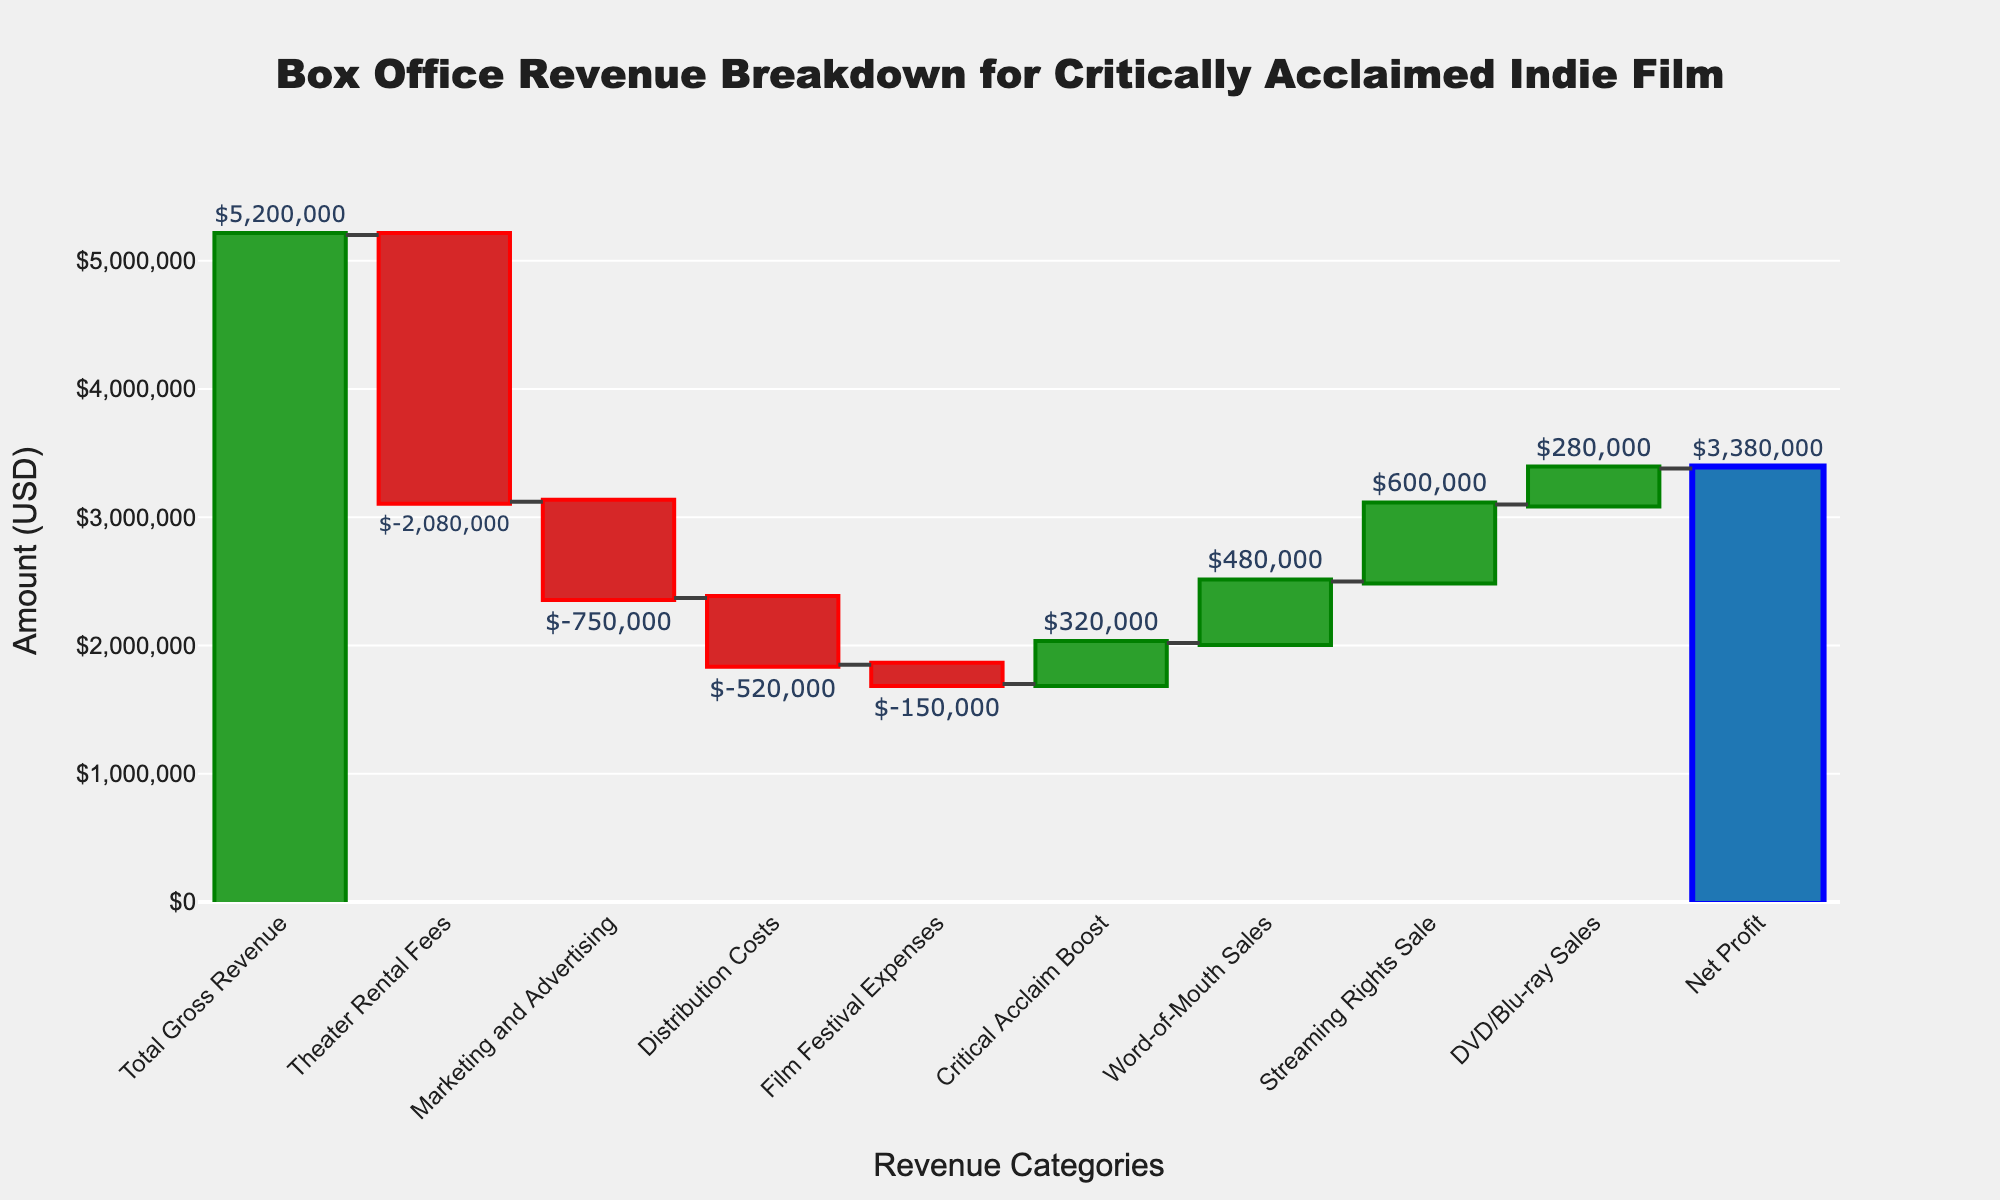What's the title of the chart? The title of the chart is typically displayed at the top and is meant to give an overview of the visualized data. In this case, the title is clearly indicated.
Answer: Box Office Revenue Breakdown for Critically Acclaimed Indie Film What is the value of the Net Profit? To find the Net Profit, look for the bar labeled "Net Profit" in the chart and read the value attached to it.
Answer: $3,380,000 How much are the Theater Rental Fees? Find the bar labeled "Theater Rental Fees" and note the value associated with it.
Answer: $-2,080,000 Which category contributes the most positively to the revenue after the "Total Gross Revenue"? Observe which of the green bars has the highest value.
Answer: Streaming Rights Sale What is the sum of Marketing and Advertising and Distribution Costs? Add the values of Marketing and Advertising ($-750,000) and Distribution Costs ($-520,000).
Answer: $-1,270,000 What are the two expenses with the smallest absolute values? By comparing the absolute values of the expenses, identify the two smallest ones.
Answer: Film Festival Expenses and Critical Acclaim Boost How much more revenue did the Word-of-Mouth Sales generate compared to Critical Acclaim Boost? Calculate the difference between the value of Word-of-Mouth Sales ($480,000) and Critical Acclaim Boost ($320,000).
Answer: $160,000 If you exclude Film Festival Expenses, what is the new cumulative revenue after Critical Acclaim Boost? Subtract the value of Film Festival Expenses ($-150,000) from the cumulative value after adding Critical Acclaim Boost ($-3,100,000 + $320,000).
Answer: $-2,780,000 What is the overall effect of the expenses on the Total Gross Revenue? Add up all the negative values to determine their collective effect on the Total Gross Revenue.
Answer: $-2,800,000 How do the Streaming Rights Sale and DVD/Blu-ray Sales compare in their contributions? Compare the values of Streaming Rights Sale ($600,000) and DVD/Blu-ray Sales ($280,000).
Answer: Streaming Rights Sale is greater 